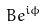<formula> <loc_0><loc_0><loc_500><loc_500>B e ^ { i \phi }</formula> 